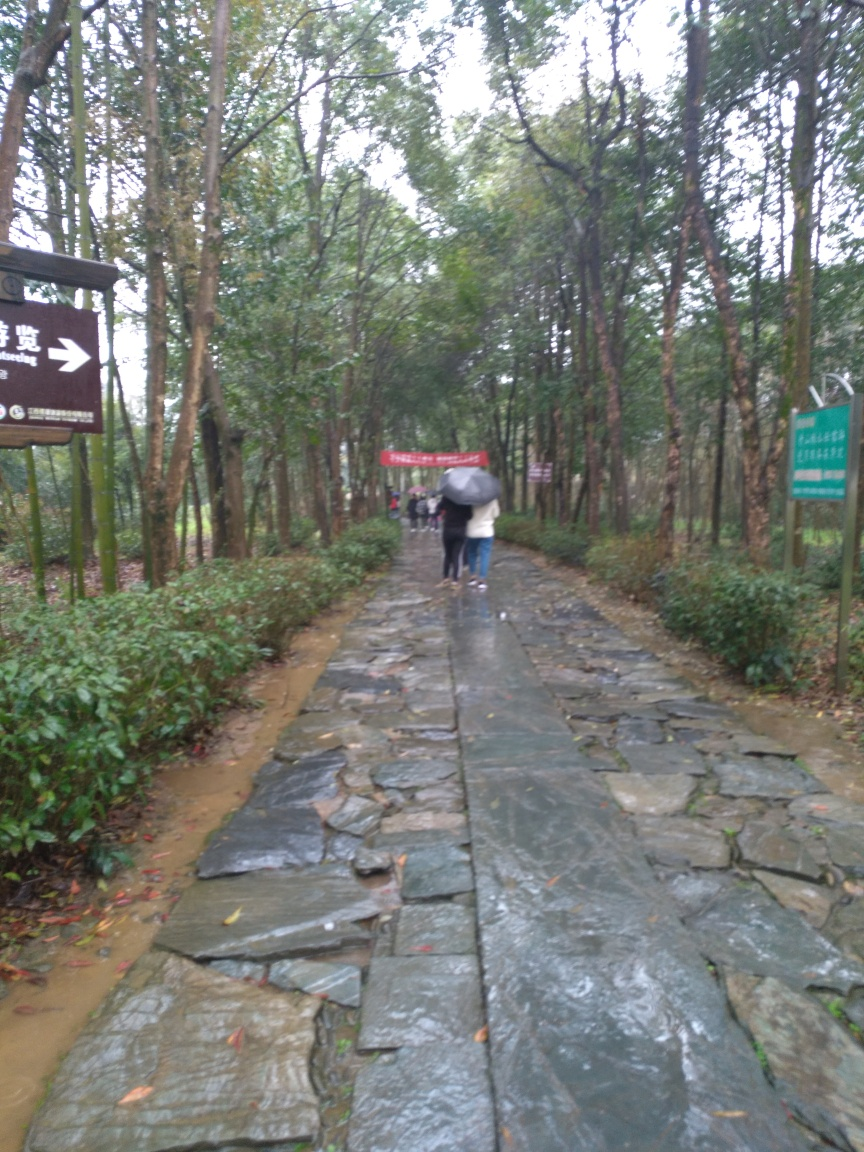Can you describe the setting of this image? The image depicts a lush, verdant pathway, likely within a park or natural area. The stone-paved trail is lined with a variety of greenery, including trees and shrubs. Overcast skies suggest a dim light setting, and a person is seen walking away from the viewpoint, holding an umbrella, which might indicate recent or present rainfall. What activities might take place on this path? This path seems ideal for leisurely activities such as walking, jogging, or nature observation. Its serene environment could also be suitable for photography, bird watching, or simply as a tranquil escape from the hustle and bustle of city life. 